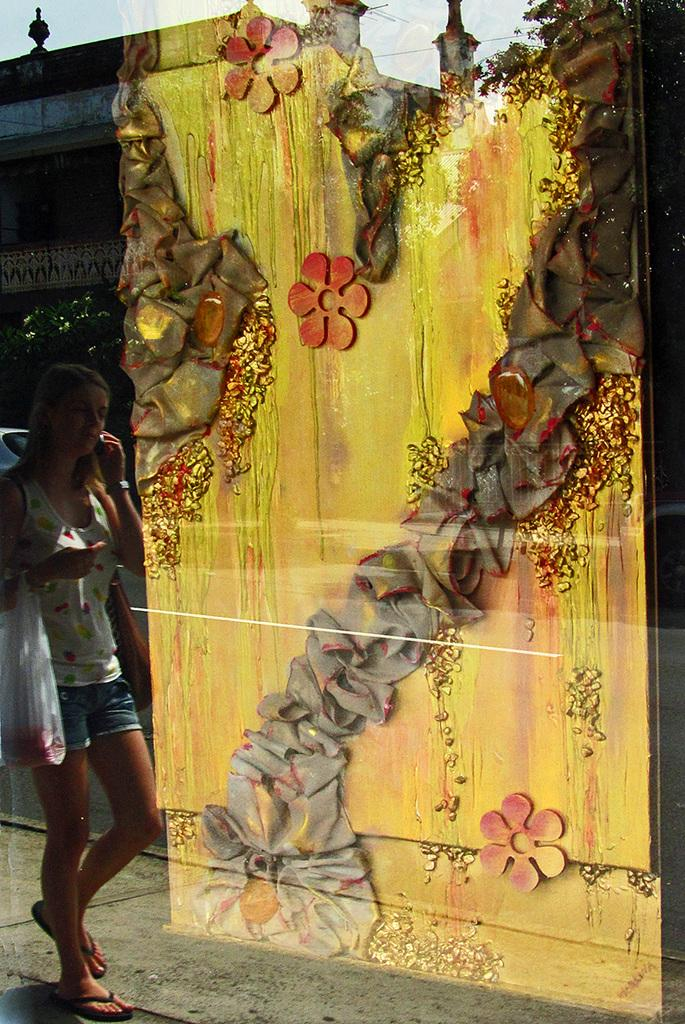Who is the main subject in the image? There is a woman in the image. What is the woman doing? The woman is walking. What is the woman holding in the image? The woman is holding a plastic bag. What can be seen on the wall in the image? There are flowers on the wall. What is at the bottom of the image? There is a road at the bottom of the image. Reasoning: Let'g: Let's think step by step in order to produce the conversation. We start by identifying the main subject in the image, which is the woman. Then, we describe her actions and what she is holding. Next, we mention the wall and the flowers on it. Finally, we describe the road at the bottom of the image. Each question is designed to elicit a specific detail about the image that is known from the provided facts. Absurd Question/Answer: What year is depicted in the image? The image does not depict a specific year; it is a photograph of a woman walking, flowers on a wall, and a road. What scale is used to measure the size of the flowers on the wall? The image does not provide information about the scale used to measure the size of the flowers on the wall. 